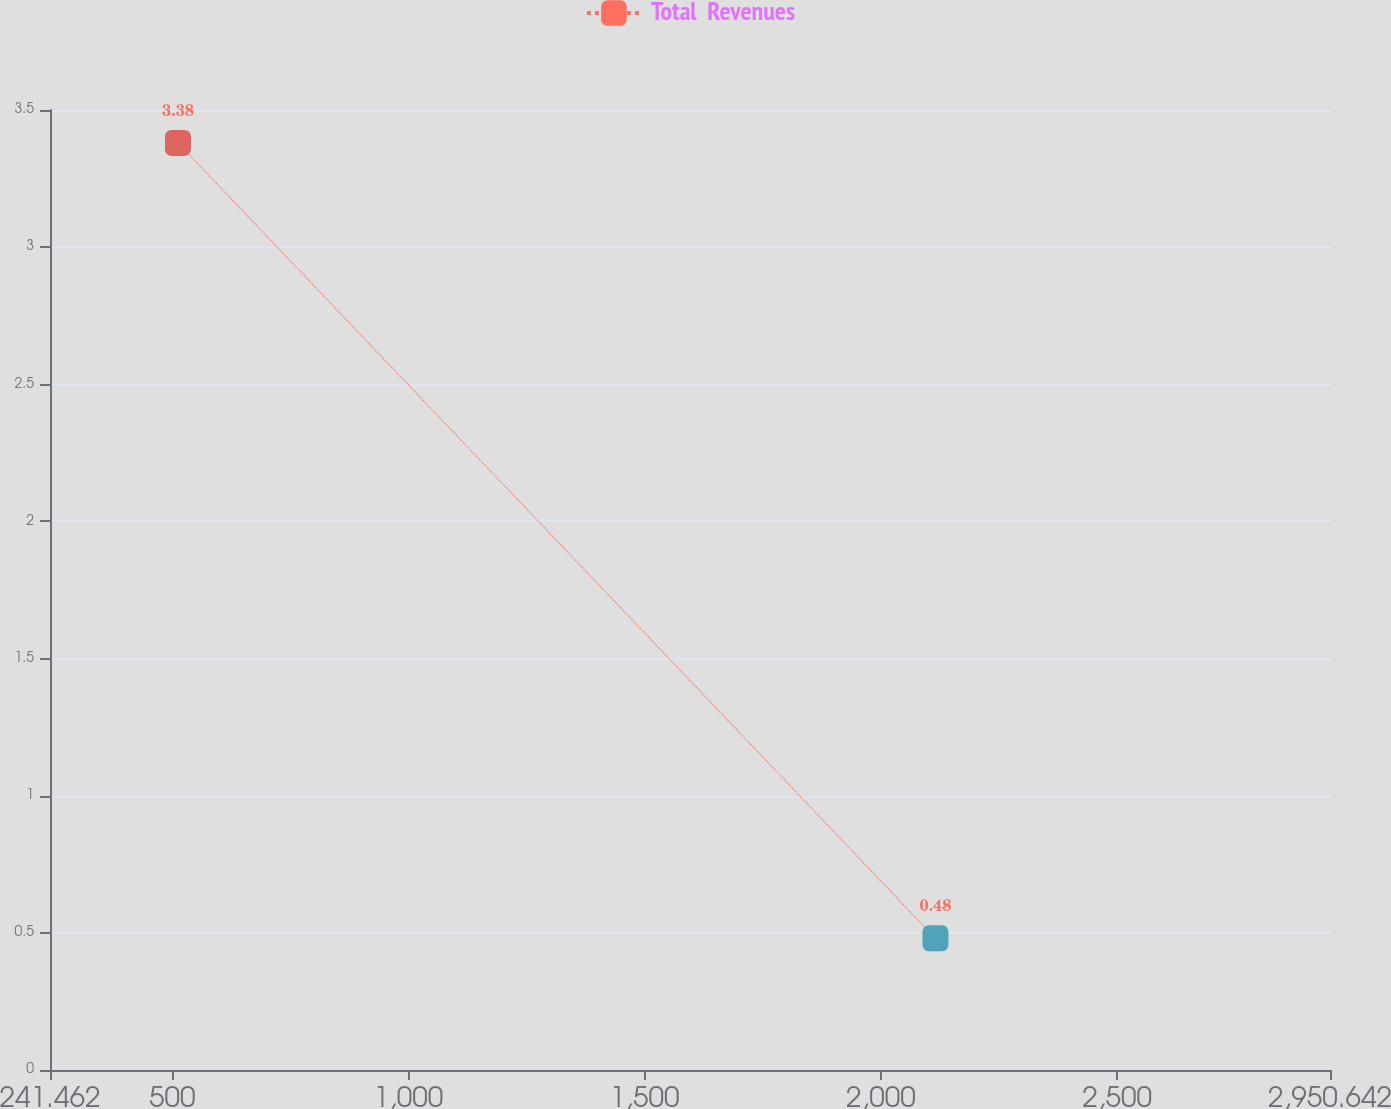Convert chart. <chart><loc_0><loc_0><loc_500><loc_500><line_chart><ecel><fcel>Total  Revenues<nl><fcel>512.38<fcel>3.38<nl><fcel>2115.62<fcel>0.48<nl><fcel>3221.56<fcel>3.68<nl></chart> 